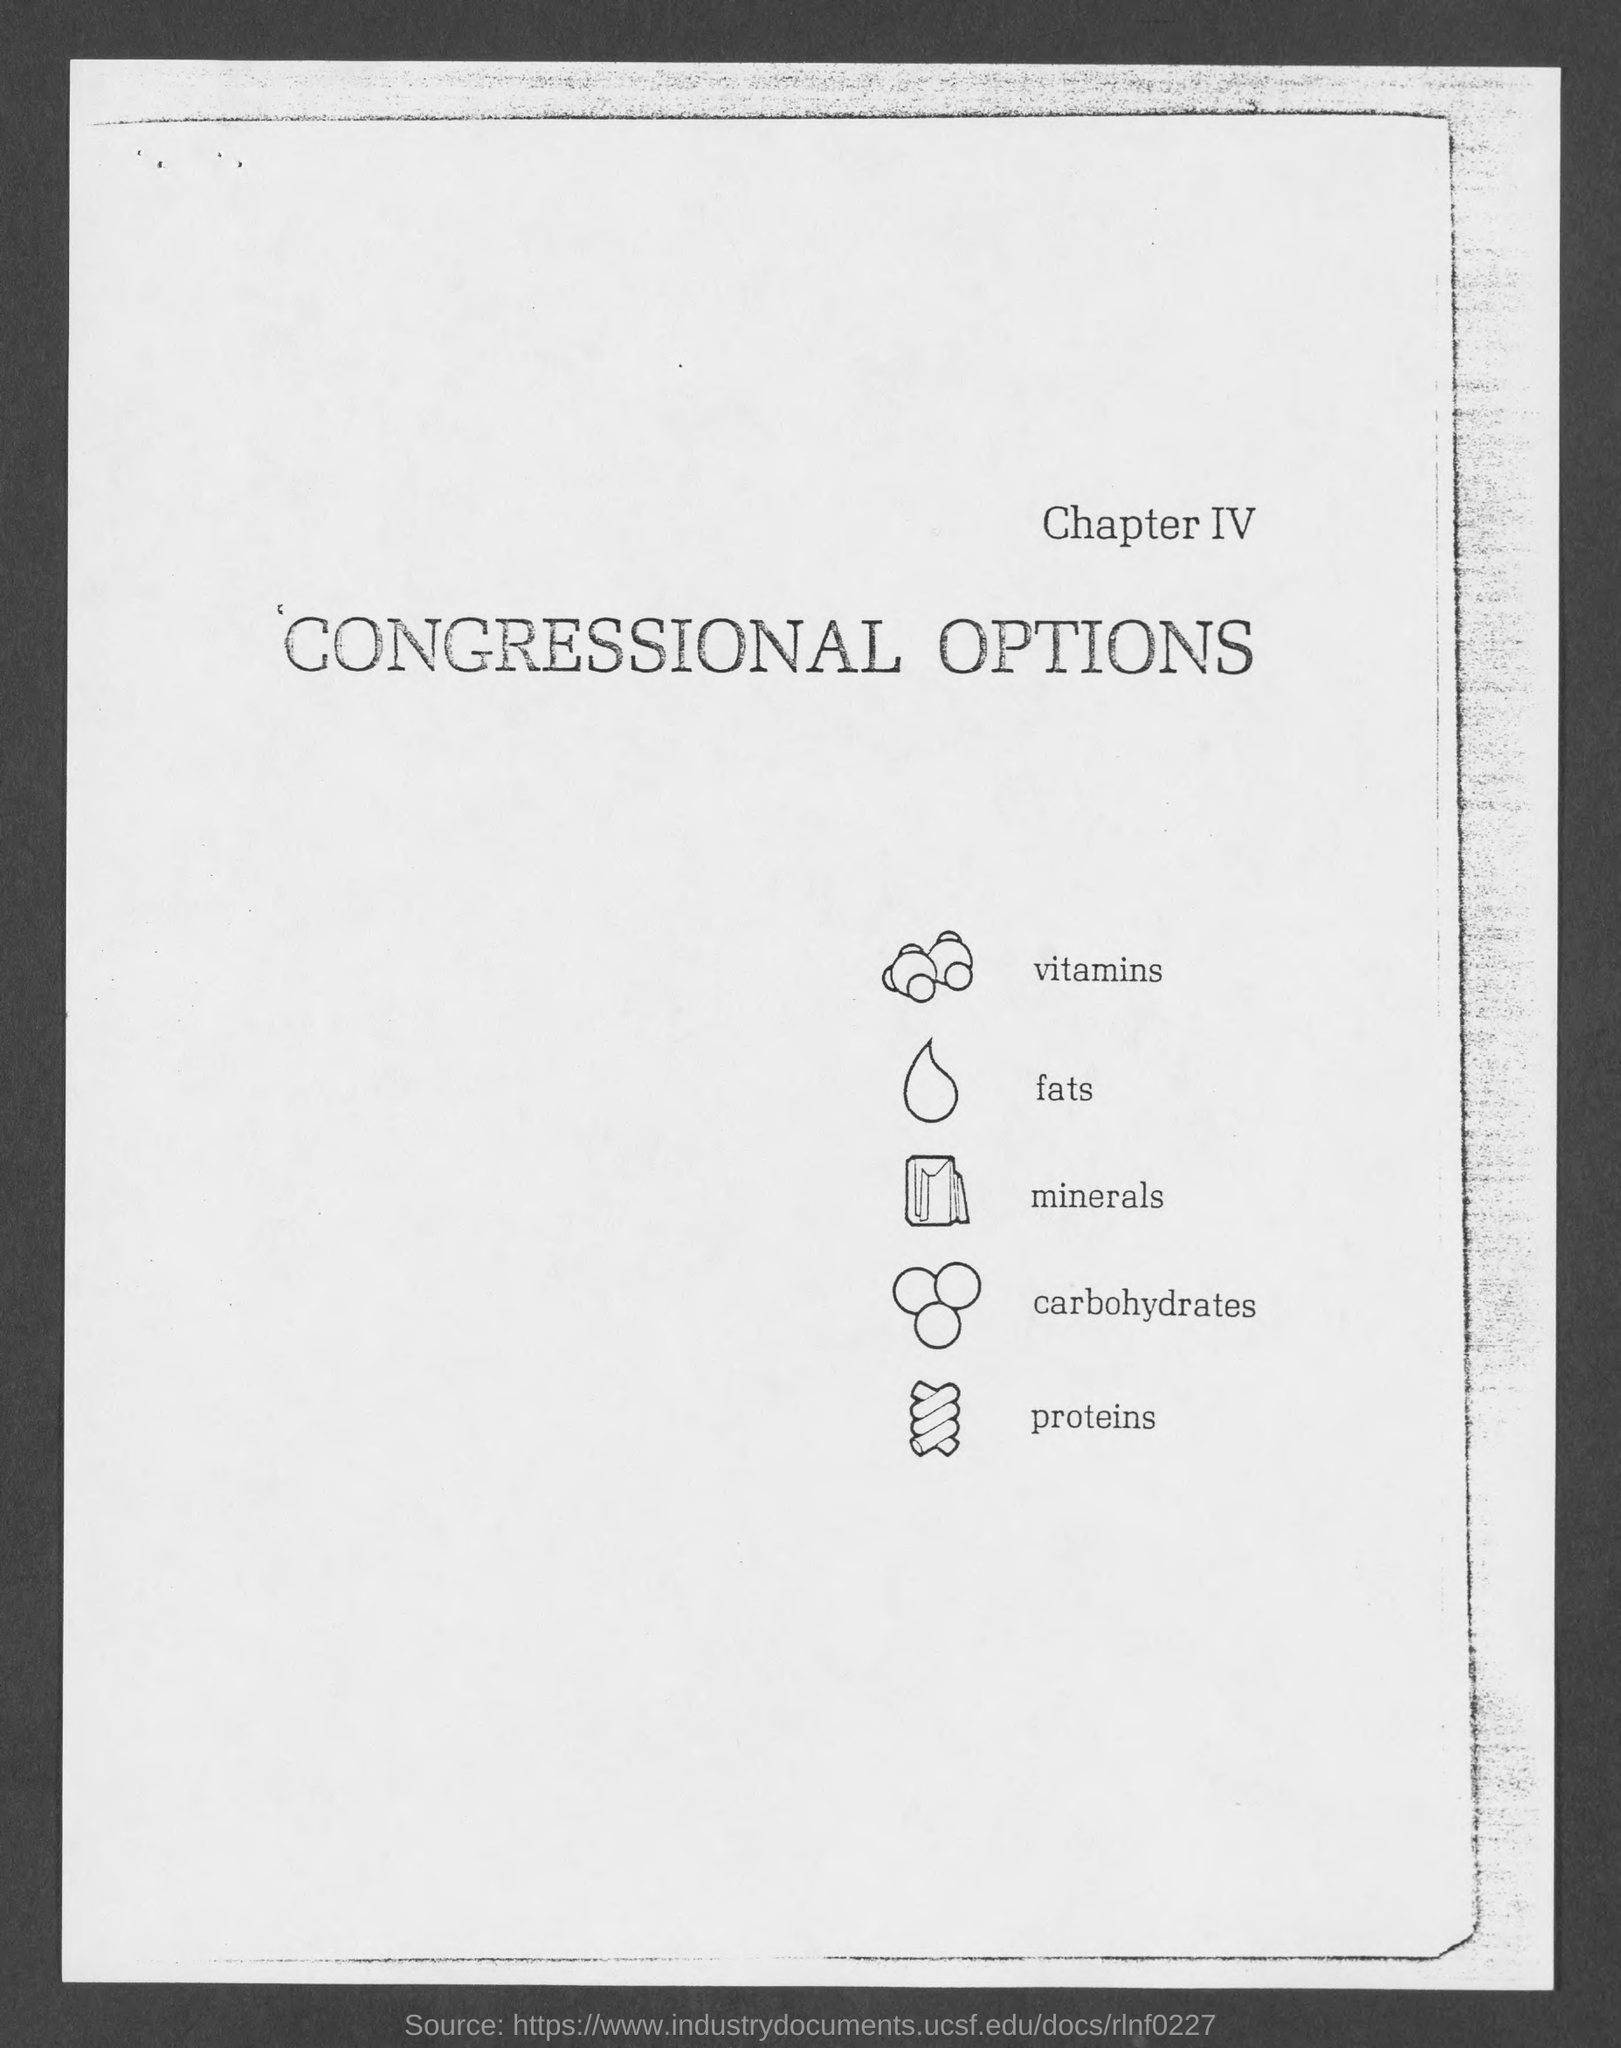What is the first title in the document?
Offer a very short reply. Chapter IV. What is the second title in the document?
Offer a terse response. Congressional Options. The first image represents which nutrient?
Your answer should be compact. Vitamins. The second image represents which nutrient?
Your answer should be compact. Fats. The third image represents which nutrient?
Your answer should be compact. Minerals. The fourth image represents which nutrient?
Provide a succinct answer. Carbohydrates. The fifth image represents which nutrient?
Offer a terse response. Proteins. 